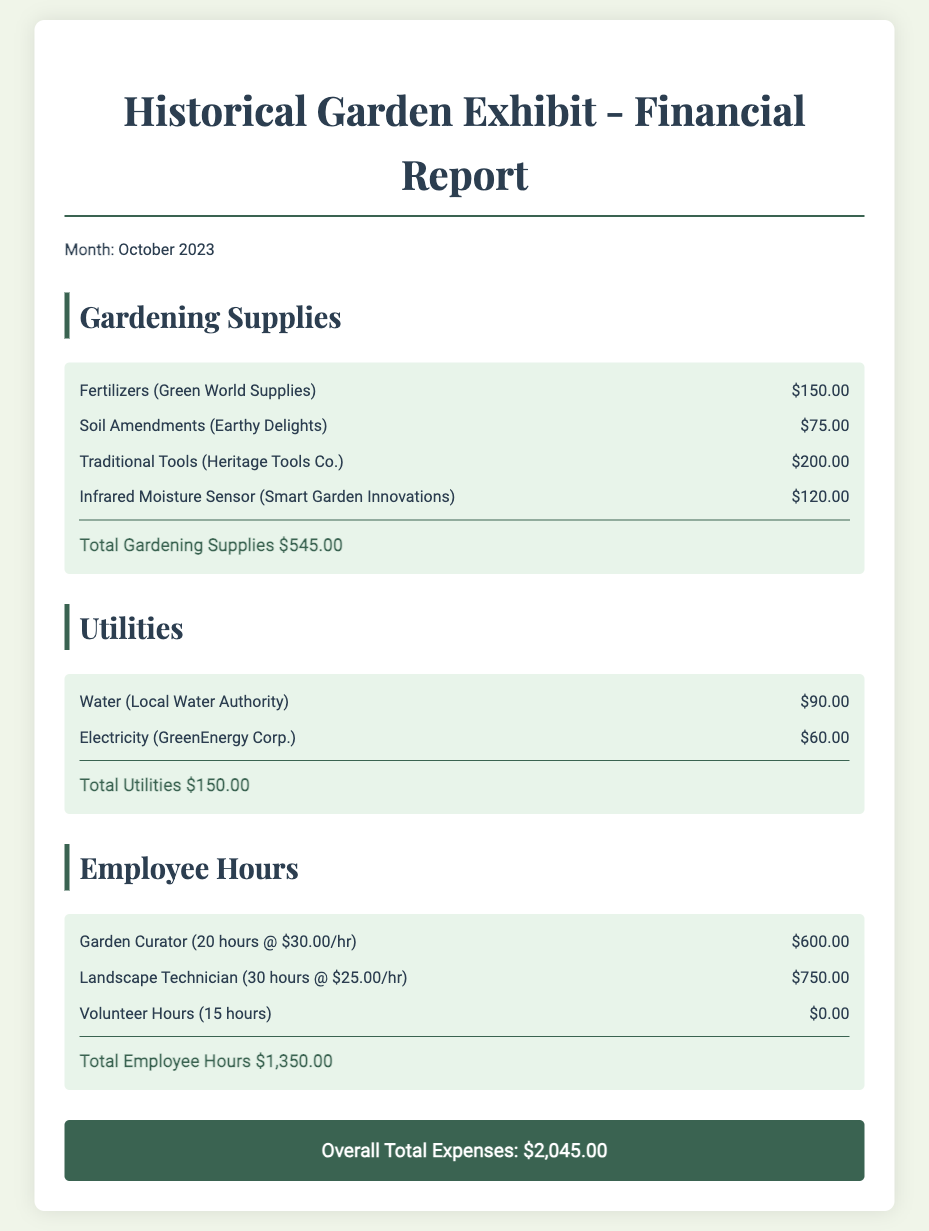what is the month of the report? The report specifies the month as October 2023.
Answer: October 2023 what is the total amount spent on gardening supplies? The total amount for gardening supplies is displayed as $545.00.
Answer: $545.00 how much was spent on utilities? The total amount for utilities is indicated as $150.00.
Answer: $150.00 what is the hourly rate for the Garden Curator? The report states that the Garden Curator's rate is $30.00 per hour.
Answer: $30.00/hr what is the overall total expenses reported? The document sums all expenses to a total of $2,045.00.
Answer: $2,045.00 how many hours did the Landscape Technician work? The report shows that the Landscape Technician worked for 30 hours.
Answer: 30 hours what is the expense for the Infrared Moisture Sensor? The expense for the Infrared Moisture Sensor is listed as $120.00.
Answer: $120.00 who provided the soil amendments? The document indicates that the soil amendments were provided by Earthy Delights.
Answer: Earthy Delights what are the three categories of expenses presented in the report? The report presents three categories: Gardening Supplies, Utilities, and Employee Hours.
Answer: Gardening Supplies, Utilities, Employee Hours 